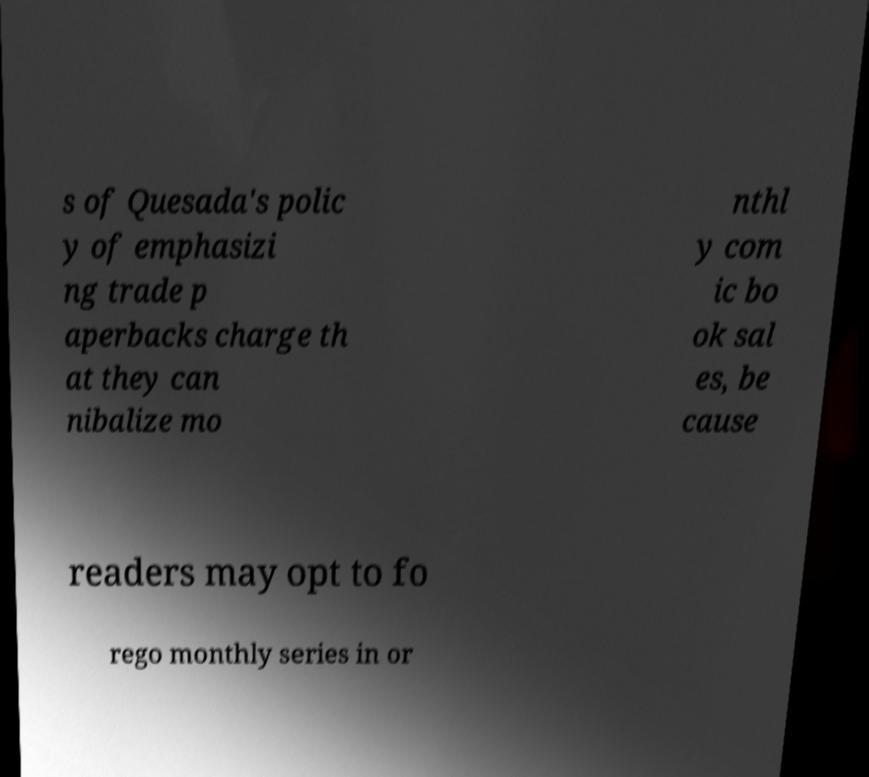Can you read and provide the text displayed in the image?This photo seems to have some interesting text. Can you extract and type it out for me? s of Quesada's polic y of emphasizi ng trade p aperbacks charge th at they can nibalize mo nthl y com ic bo ok sal es, be cause readers may opt to fo rego monthly series in or 